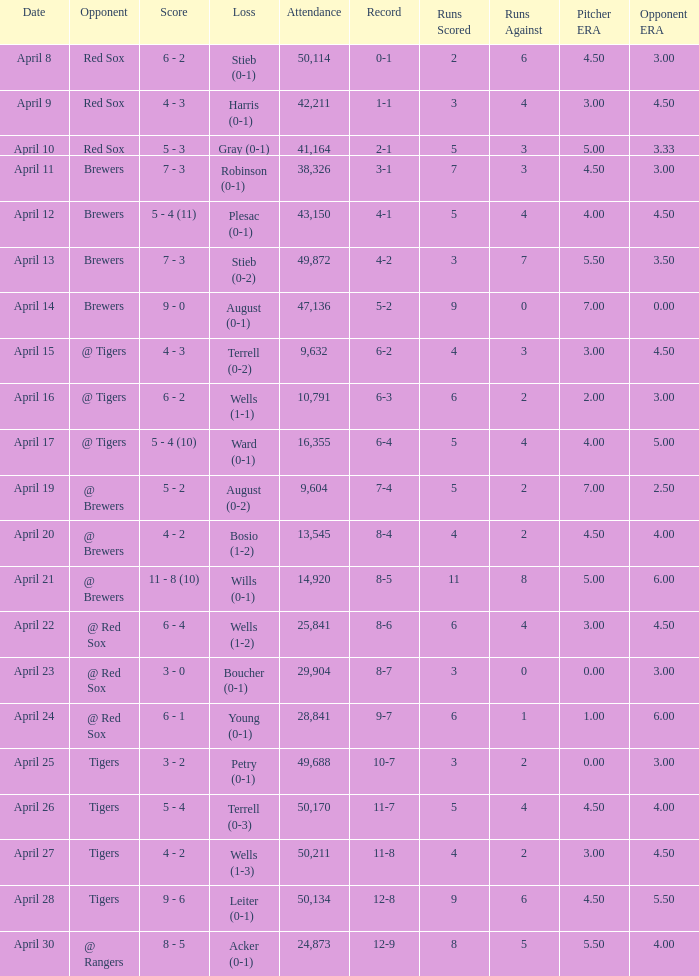Which opponent has a loss of wells (1-3)? Tigers. 